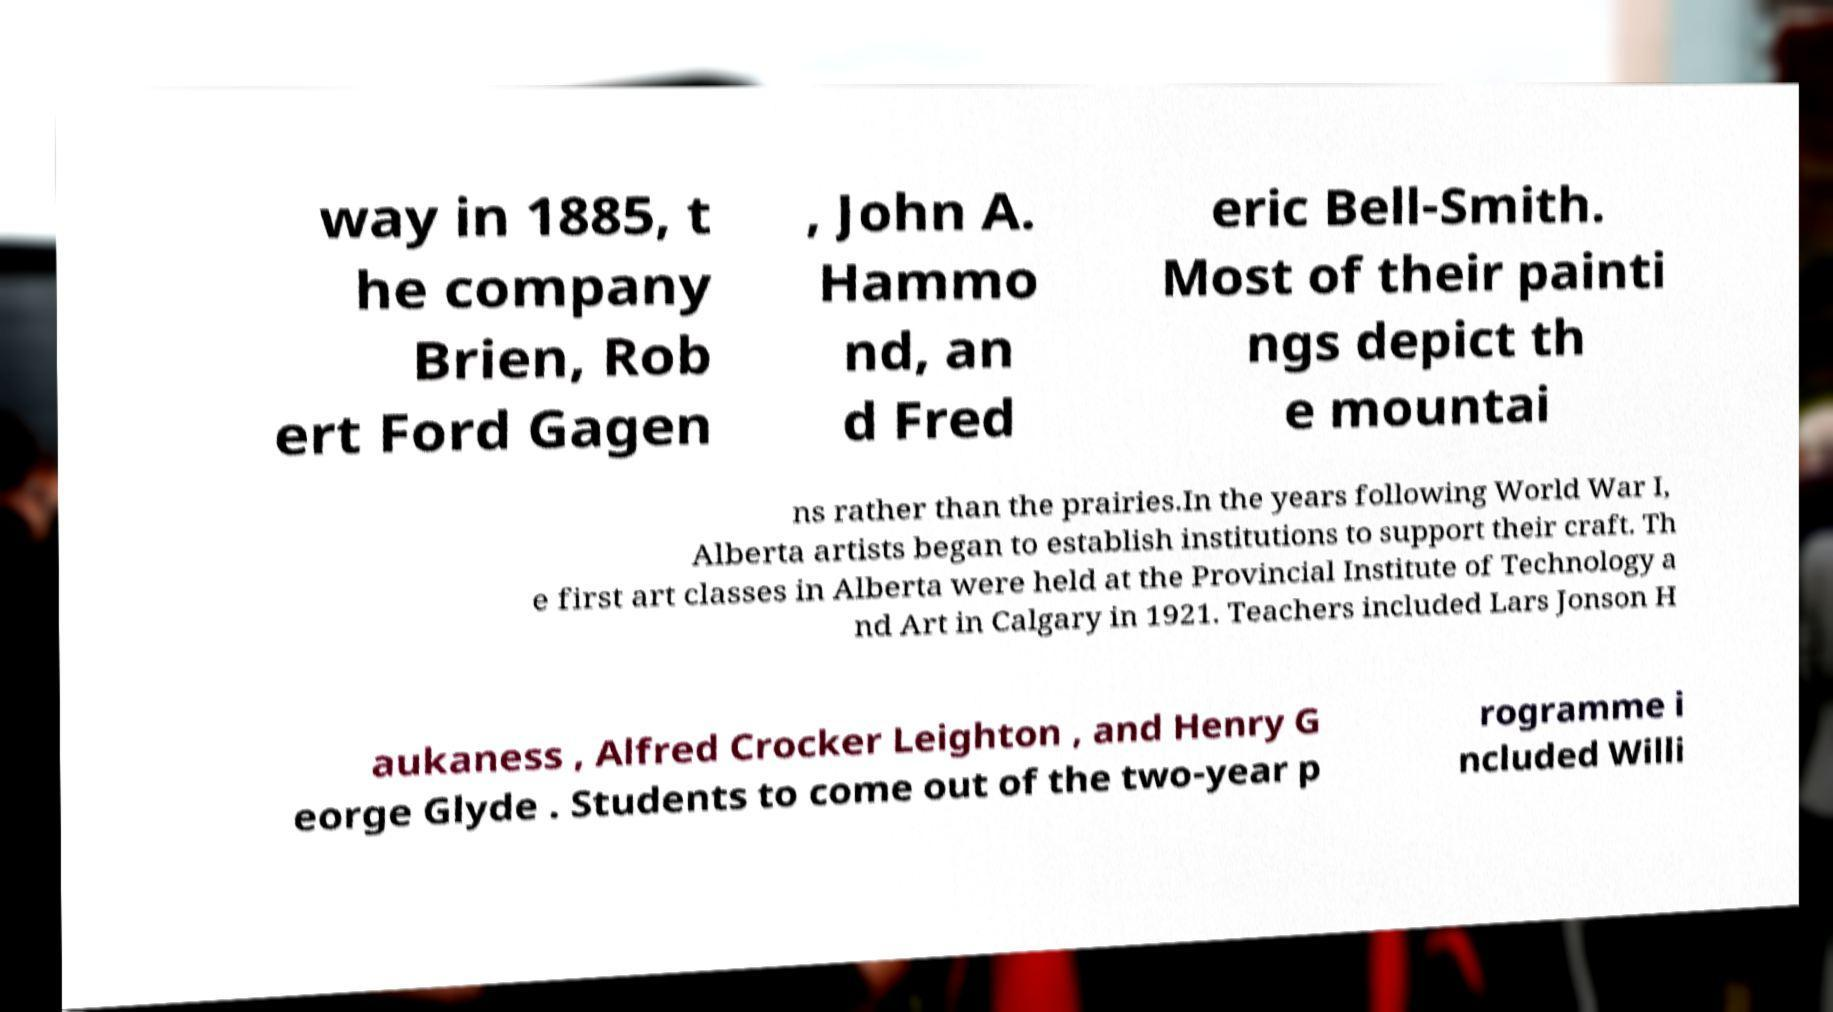Could you assist in decoding the text presented in this image and type it out clearly? way in 1885, t he company Brien, Rob ert Ford Gagen , John A. Hammo nd, an d Fred eric Bell-Smith. Most of their painti ngs depict th e mountai ns rather than the prairies.In the years following World War I, Alberta artists began to establish institutions to support their craft. Th e first art classes in Alberta were held at the Provincial Institute of Technology a nd Art in Calgary in 1921. Teachers included Lars Jonson H aukaness , Alfred Crocker Leighton , and Henry G eorge Glyde . Students to come out of the two-year p rogramme i ncluded Willi 